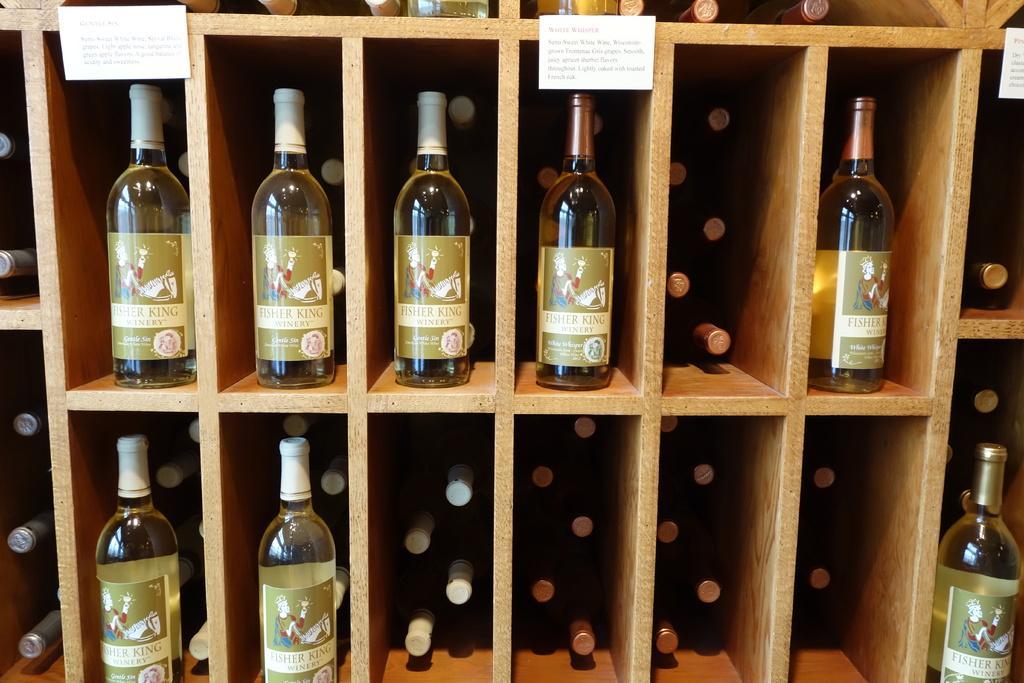Can you describe this image briefly? In this image I see number of bottles in the racks and I see 3 papers over here. 